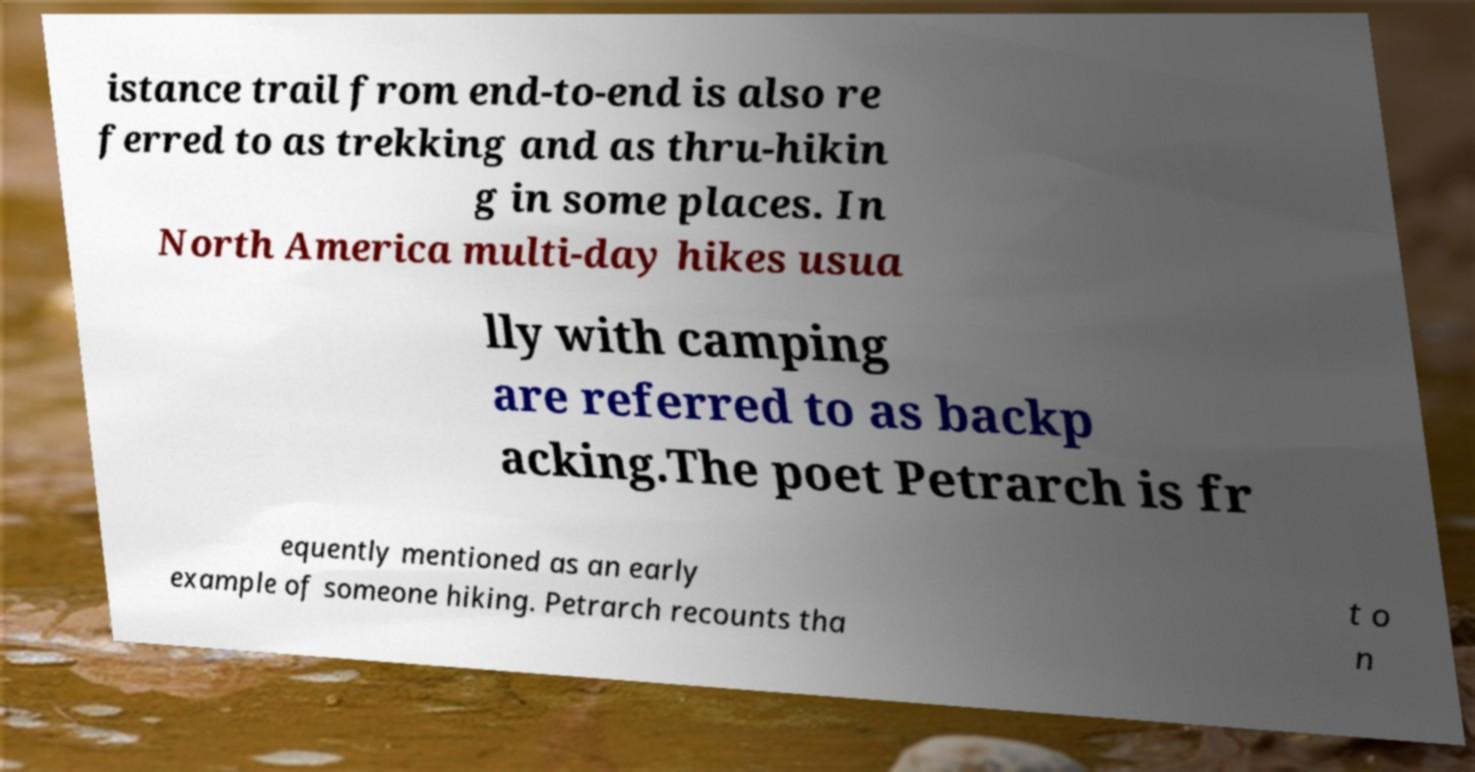I need the written content from this picture converted into text. Can you do that? istance trail from end-to-end is also re ferred to as trekking and as thru-hikin g in some places. In North America multi-day hikes usua lly with camping are referred to as backp acking.The poet Petrarch is fr equently mentioned as an early example of someone hiking. Petrarch recounts tha t o n 